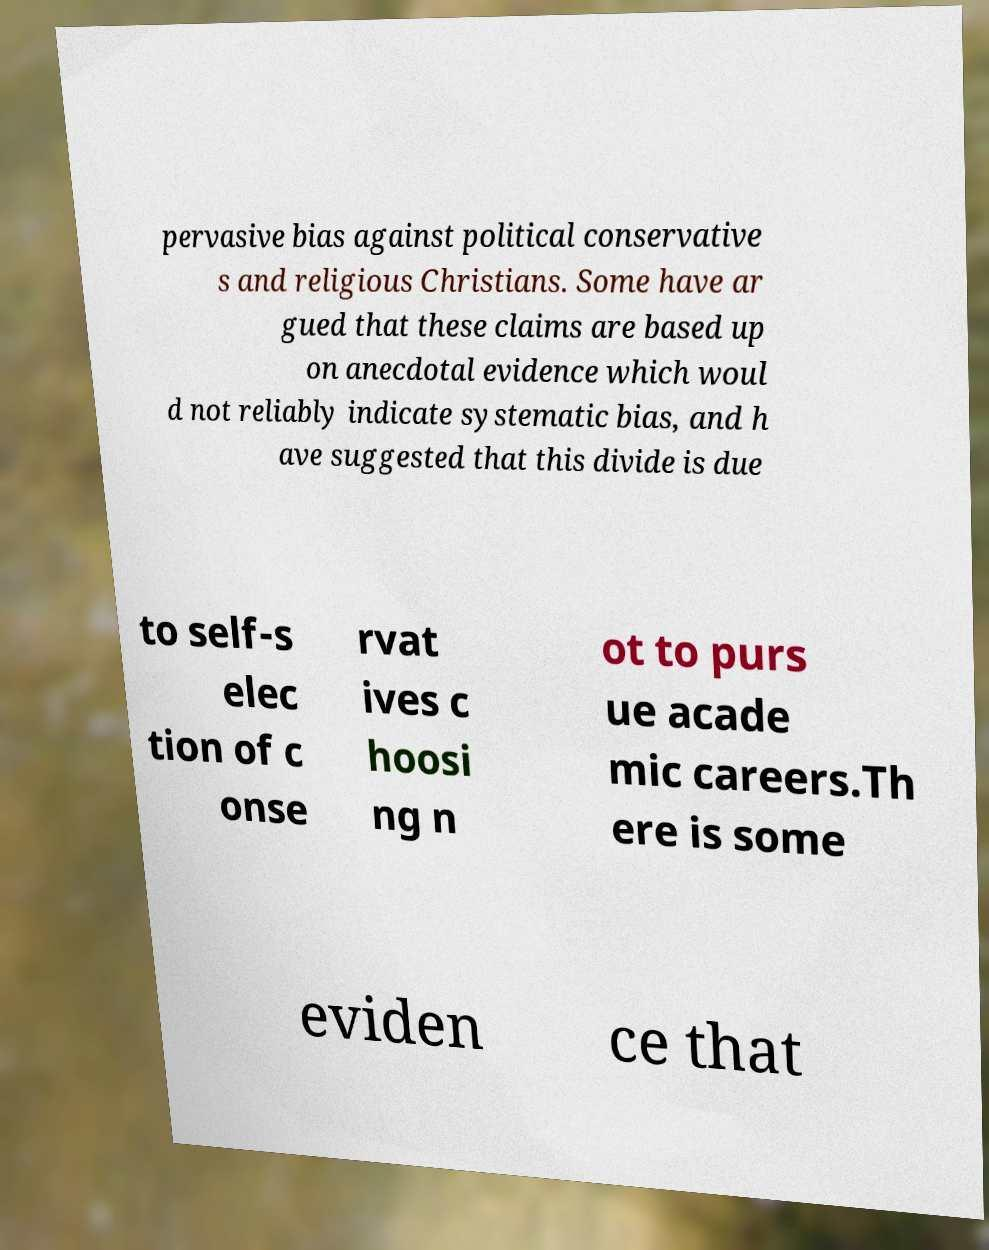What messages or text are displayed in this image? I need them in a readable, typed format. pervasive bias against political conservative s and religious Christians. Some have ar gued that these claims are based up on anecdotal evidence which woul d not reliably indicate systematic bias, and h ave suggested that this divide is due to self-s elec tion of c onse rvat ives c hoosi ng n ot to purs ue acade mic careers.Th ere is some eviden ce that 